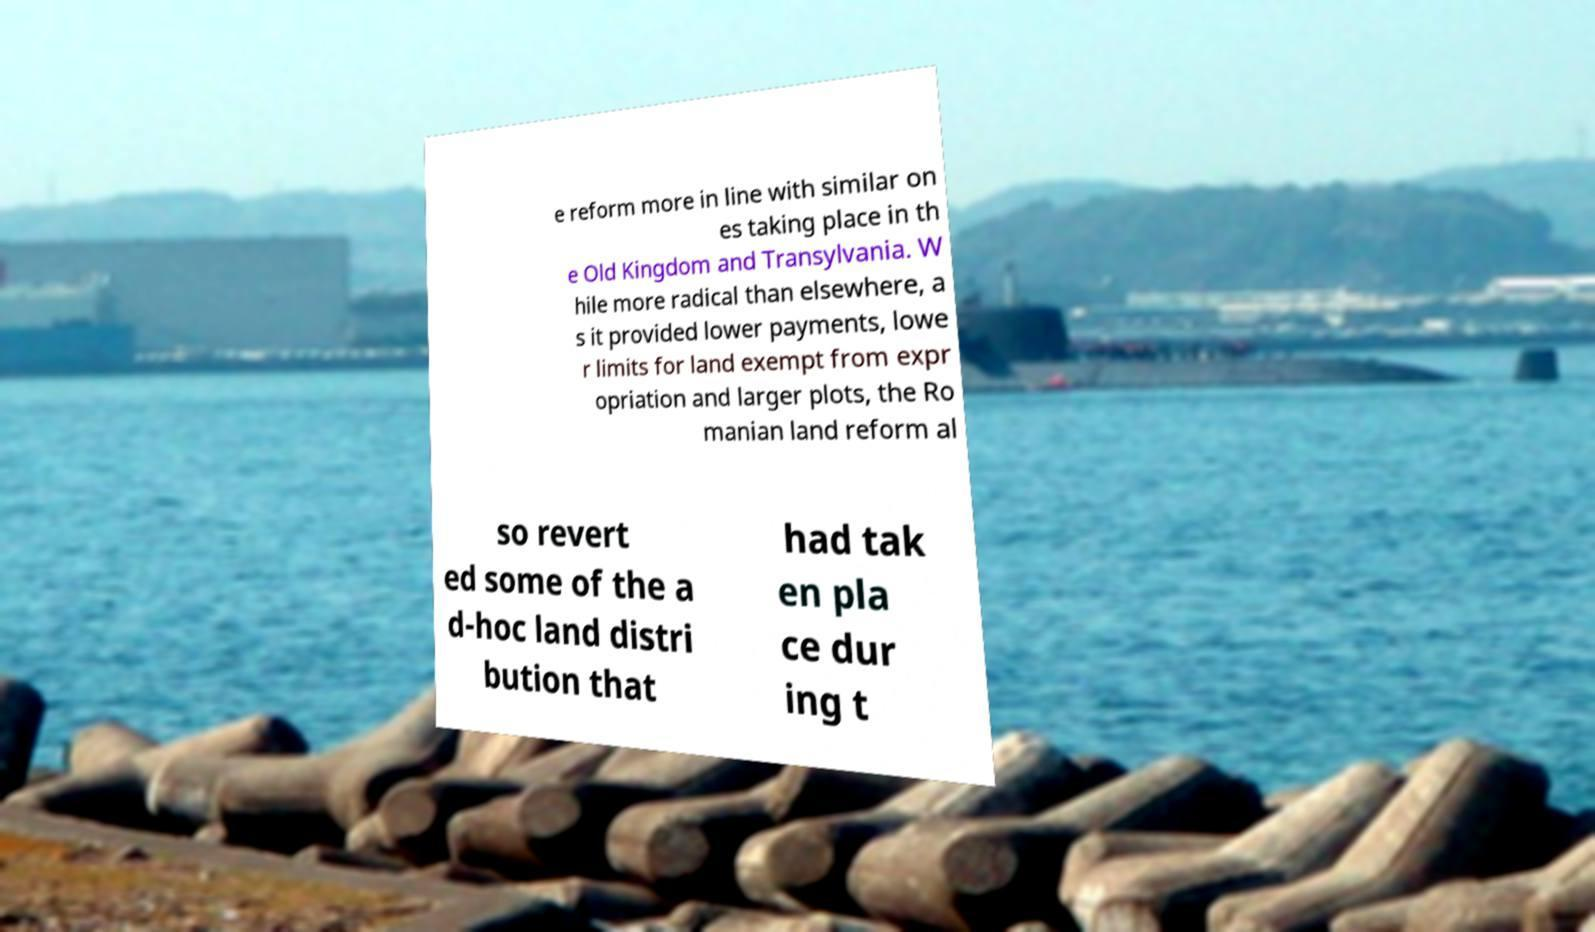Please identify and transcribe the text found in this image. e reform more in line with similar on es taking place in th e Old Kingdom and Transylvania. W hile more radical than elsewhere, a s it provided lower payments, lowe r limits for land exempt from expr opriation and larger plots, the Ro manian land reform al so revert ed some of the a d-hoc land distri bution that had tak en pla ce dur ing t 